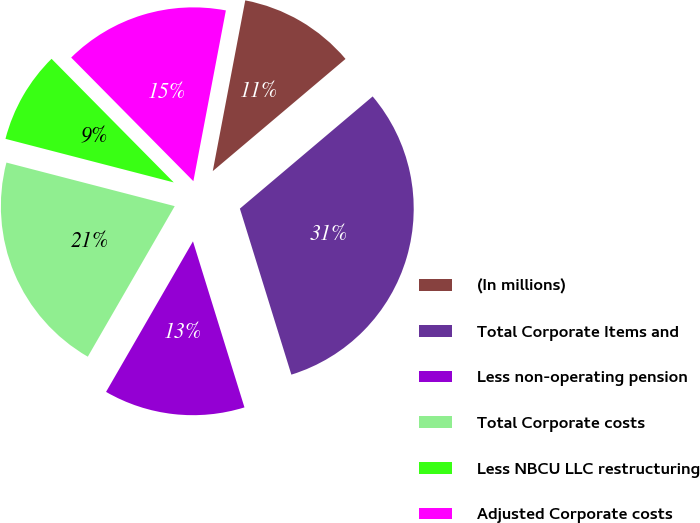Convert chart to OTSL. <chart><loc_0><loc_0><loc_500><loc_500><pie_chart><fcel>(In millions)<fcel>Total Corporate Items and<fcel>Less non-operating pension<fcel>Total Corporate costs<fcel>Less NBCU LLC restructuring<fcel>Adjusted Corporate costs<nl><fcel>10.84%<fcel>31.38%<fcel>13.12%<fcel>20.7%<fcel>8.56%<fcel>15.4%<nl></chart> 